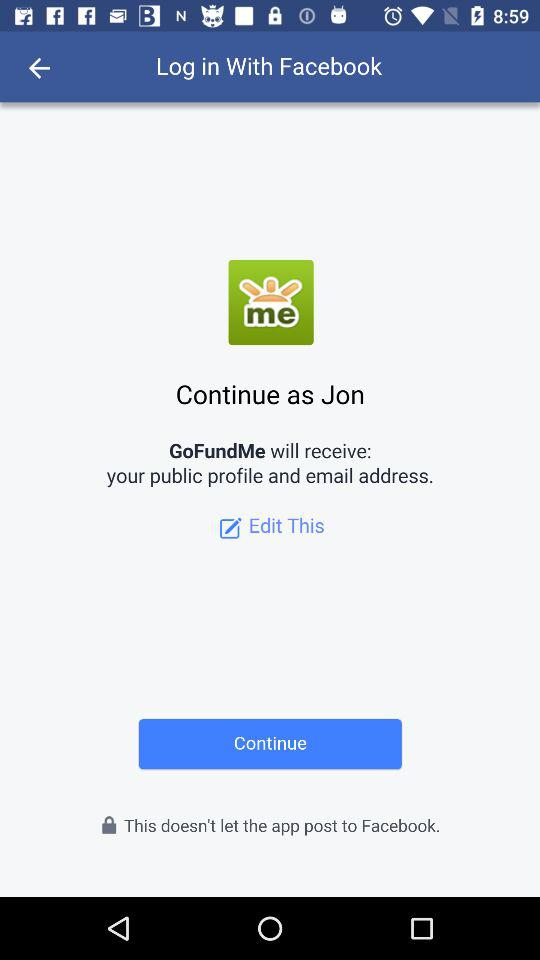What application is asking for permission? The application asking for permission is "GoFundMe". 